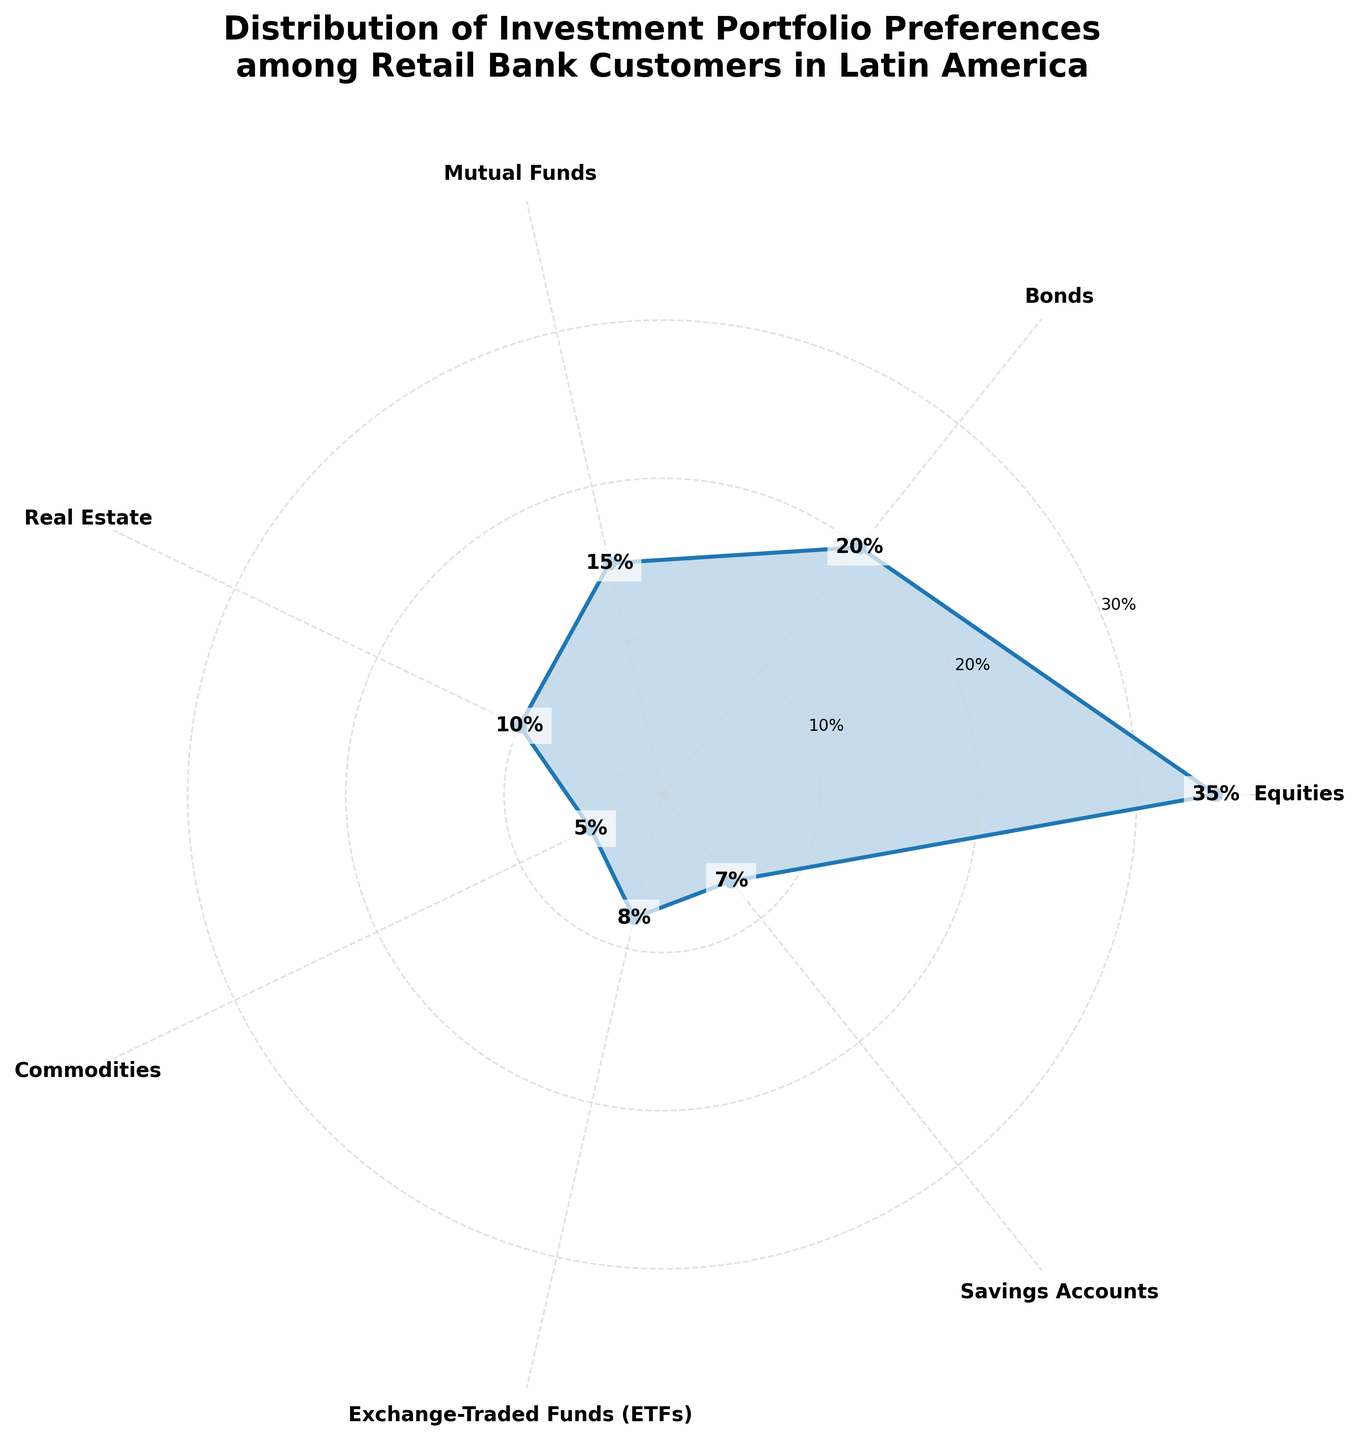Which category has the highest percentage of the investment portfolio preferences? The figure shows the different categories of investment portfolios and their corresponding percentages. By observing the length of each segment, "Equities" has the highest percentage.
Answer: Equities What's the percentage of Bonds in the investment portfolios? The plot includes a segment for each investment category with their respective percentages labeled. The percentage for Bonds is labeled as 20%.
Answer: 20% What is the combined percentage of Mutual Funds, Real Estate, and Commodities? To find the combined percentage, add the individual percentages of Mutual Funds (15%), Real Estate (10%), and Commodities (5%). 15% + 10% + 5% = 30%
Answer: 30% How much higher is the percentage of Equities compared to Savings Accounts? The percentage of Equities is 35%, and the percentage of Savings Accounts is 7%. The difference is calculated by subtracting 7% from 35%. 35% - 7% = 28%
Answer: 28% Which categories have percentages less than 10%? Observing the categories and their percentages, Real Estate (10%), Commodities (5%), Exchange-Traded Funds (ETFs) (8%), and Savings Accounts (7%) are below 10%.
Answer: Commodities, Exchange-Traded Funds (ETFs), Savings Accounts What is the average percentage of all the investment categories? Sum the percentages of all categories (35% + 20% + 15% + 10% + 5% + 8% + 7%) and divide by the number of categories (7). Total is 100%, so average is 100% / 7 ≈ 14.29%
Answer: 14.29% Which category is closest to the average percentage value? The average percentage calculated is approximately 14.29%. By comparing the percentages of each category, Mutual Funds (15%) is the closest to this average.
Answer: Mutual Funds What is the smallest category by percentage in the investment portfolio? The figure shows various investment categories and their percentages. By comparing the lengths of segments, Commodities has the smallest percentage at 5%.
Answer: Commodities How much more popular are Equities compared to ETFs? The percentage for Equities is 35%, while for ETFs it is 8%. Subtracting the ETFs value from the Equities value gives 35% - 8% = 27%.
Answer: 27% In a verbal summary, what does the figure illustrate? The figure is a polar area chart that visualizes the distribution of investment portfolio preferences among retail bank customers in Latin America, displaying the percentage share for each investment category.
Answer: Distribution of investment portfolio preferences in Latin America 